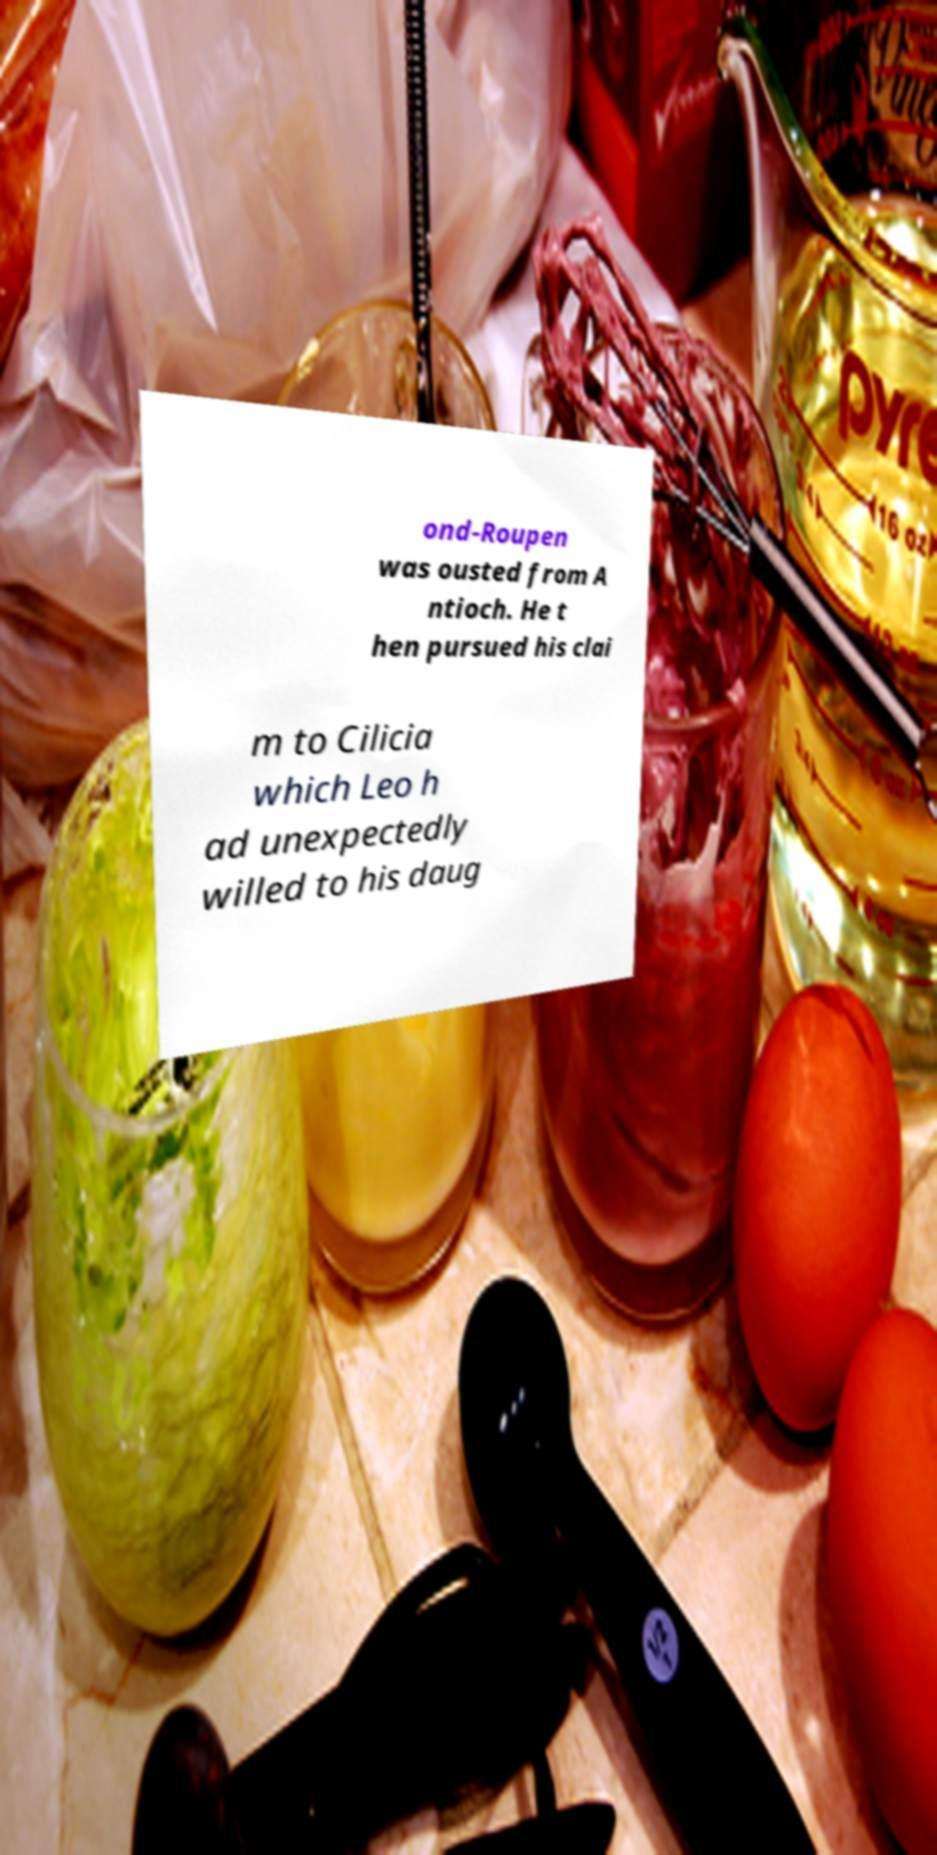Can you accurately transcribe the text from the provided image for me? ond-Roupen was ousted from A ntioch. He t hen pursued his clai m to Cilicia which Leo h ad unexpectedly willed to his daug 